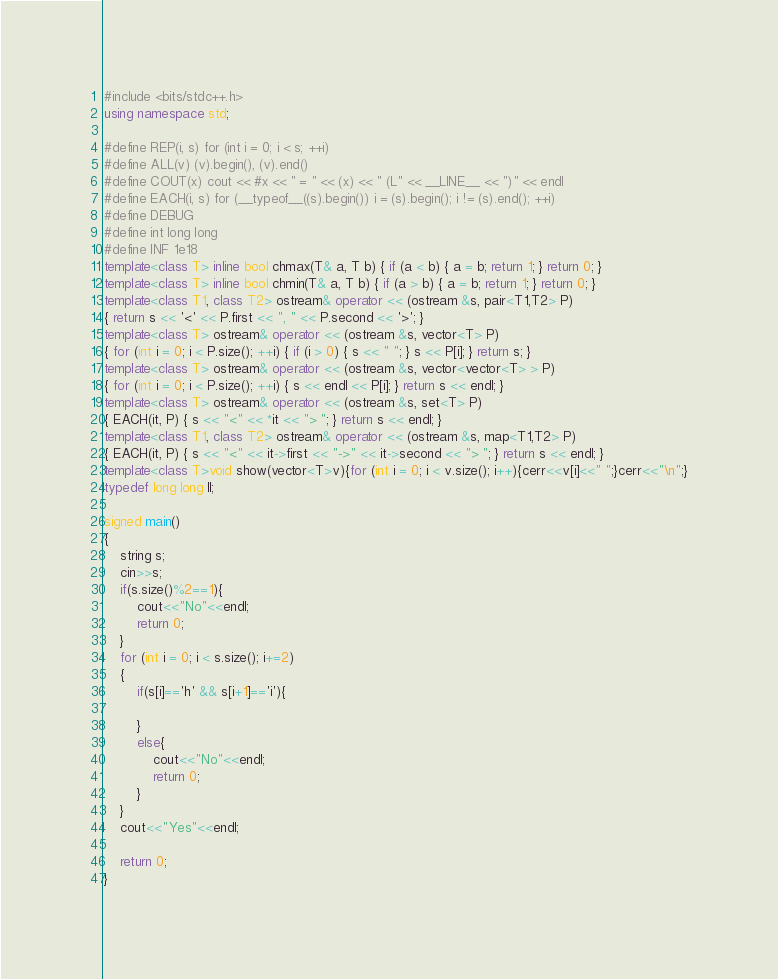Convert code to text. <code><loc_0><loc_0><loc_500><loc_500><_C++_>#include <bits/stdc++.h>
using namespace std;
 
#define REP(i, s) for (int i = 0; i < s; ++i)
#define ALL(v) (v).begin(), (v).end()
#define COUT(x) cout << #x << " = " << (x) << " (L" << __LINE__ << ")" << endl
#define EACH(i, s) for (__typeof__((s).begin()) i = (s).begin(); i != (s).end(); ++i)
#define DEBUG
#define int long long
#define INF 1e18
template<class T> inline bool chmax(T& a, T b) { if (a < b) { a = b; return 1; } return 0; }
template<class T> inline bool chmin(T& a, T b) { if (a > b) { a = b; return 1; } return 0; }
template<class T1, class T2> ostream& operator << (ostream &s, pair<T1,T2> P)
{ return s << '<' << P.first << ", " << P.second << '>'; }
template<class T> ostream& operator << (ostream &s, vector<T> P)
{ for (int i = 0; i < P.size(); ++i) { if (i > 0) { s << " "; } s << P[i]; } return s; }
template<class T> ostream& operator << (ostream &s, vector<vector<T> > P)
{ for (int i = 0; i < P.size(); ++i) { s << endl << P[i]; } return s << endl; }
template<class T> ostream& operator << (ostream &s, set<T> P)
{ EACH(it, P) { s << "<" << *it << "> "; } return s << endl; }
template<class T1, class T2> ostream& operator << (ostream &s, map<T1,T2> P)
{ EACH(it, P) { s << "<" << it->first << "->" << it->second << "> "; } return s << endl; }
template<class T>void show(vector<T>v){for (int i = 0; i < v.size(); i++){cerr<<v[i]<<" ";}cerr<<"\n";}
typedef long long ll;

signed main()
{
    string s;
    cin>>s;
    if(s.size()%2==1){
        cout<<"No"<<endl;
        return 0;
    }
    for (int i = 0; i < s.size(); i+=2)
    {
        if(s[i]=='h' && s[i+1]=='i'){

        }
        else{
            cout<<"No"<<endl;
            return 0;
        }
    }
    cout<<"Yes"<<endl;
    
    return 0;
}</code> 